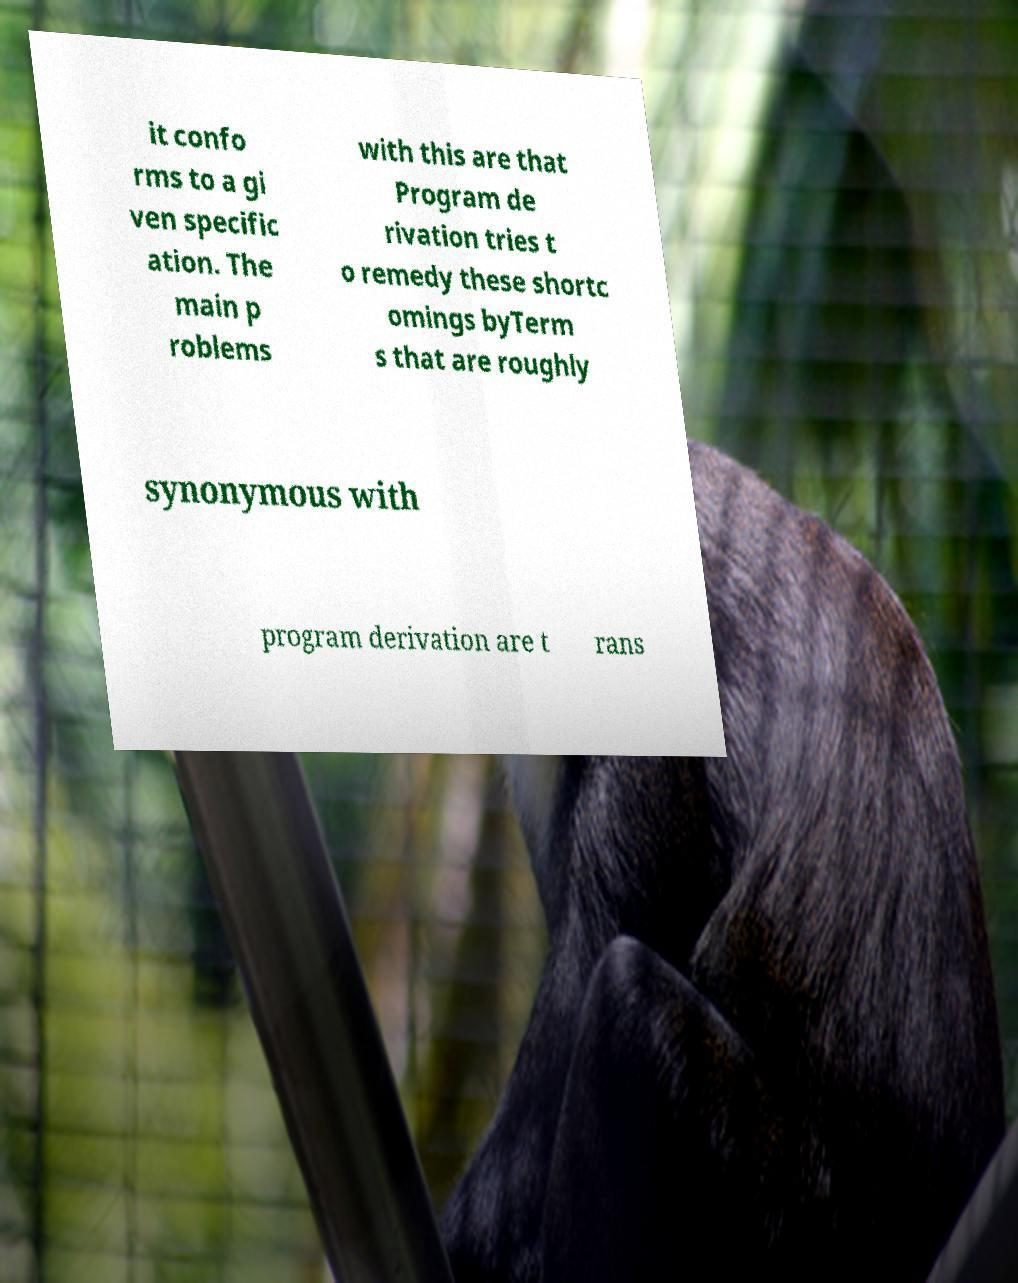For documentation purposes, I need the text within this image transcribed. Could you provide that? it confo rms to a gi ven specific ation. The main p roblems with this are that Program de rivation tries t o remedy these shortc omings byTerm s that are roughly synonymous with program derivation are t rans 